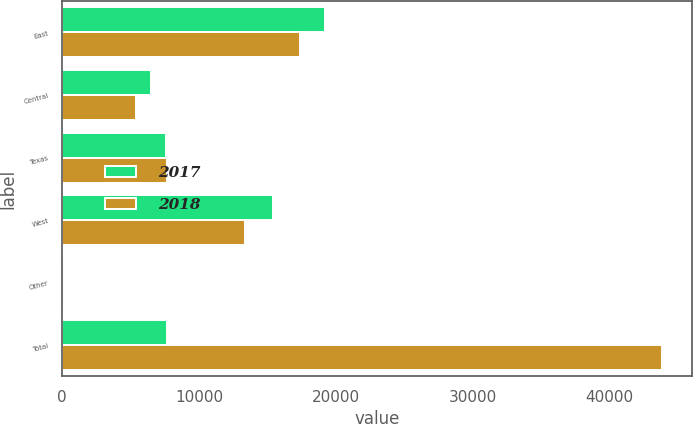Convert chart. <chart><loc_0><loc_0><loc_500><loc_500><stacked_bar_chart><ecel><fcel>East<fcel>Central<fcel>Texas<fcel>West<fcel>Other<fcel>Total<nl><fcel>2017<fcel>19231<fcel>6506<fcel>7582<fcel>15434<fcel>103<fcel>7635<nl><fcel>2018<fcel>17339<fcel>5376<fcel>7635<fcel>13355<fcel>123<fcel>43828<nl></chart> 